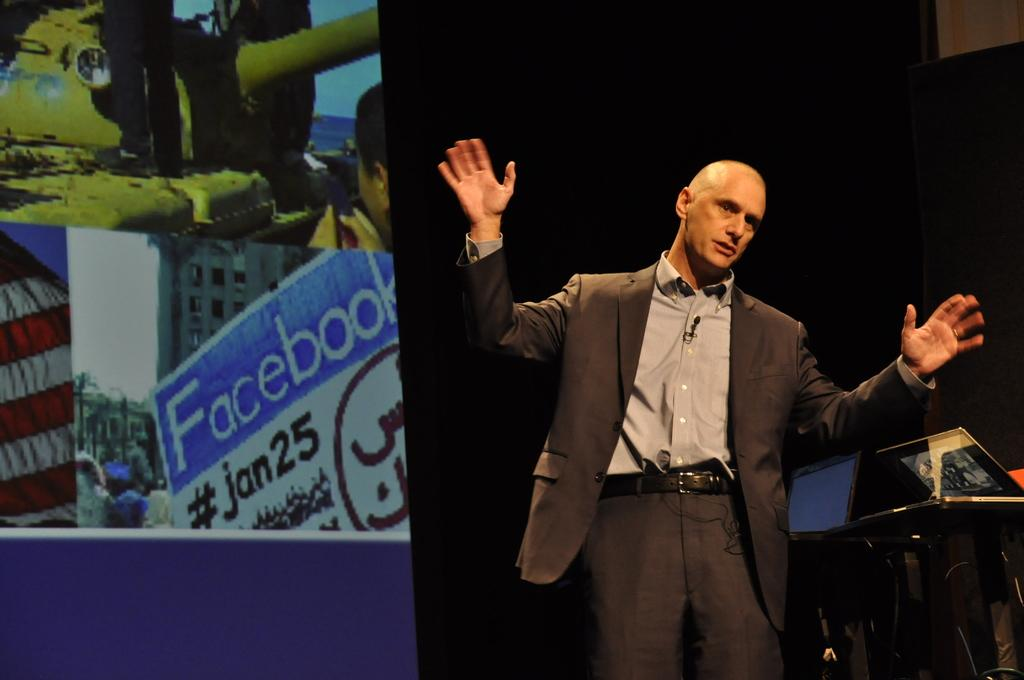Who is present in the image? There is a man in the image. What is the man wearing? The man is wearing a blazer. What is the man doing in the image? The man is standing. What type of electronic devices can be seen in the image? There are laptops on stands in the image. What is visible on the screen in the image? There is a screen visible in the image. How would you describe the lighting in the image? The background of the image is dark. What type of berry is being used as a border in the image? There is no berry or border present in the image. Can you see a kite flying in the background of the image? There is no kite visible in the image. 